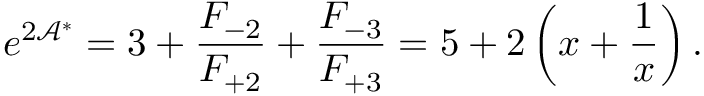Convert formula to latex. <formula><loc_0><loc_0><loc_500><loc_500>e ^ { 2 \mathcal { A } ^ { \ast } } = 3 + \frac { F _ { - 2 } } { F _ { + 2 } } + \frac { F _ { - 3 } } { F _ { + 3 } } = 5 + 2 \left ( x + \frac { 1 } { x } \right ) .</formula> 